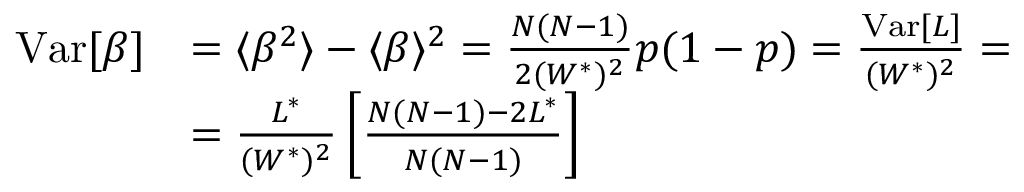<formula> <loc_0><loc_0><loc_500><loc_500>\begin{array} { r l } { V a r [ \beta ] } & { = \langle \beta ^ { 2 } \rangle - \langle \beta \rangle ^ { 2 } = \frac { N ( N - 1 ) } { 2 ( W ^ { * } ) ^ { 2 } } p ( 1 - p ) = \frac { V a r [ L ] } { ( W ^ { * } ) ^ { 2 } } = } \\ & { = \frac { L ^ { * } } { ( W ^ { * } ) ^ { 2 } } \left [ \frac { N ( N - 1 ) - 2 L ^ { * } } { N ( N - 1 ) } \right ] } \end{array}</formula> 